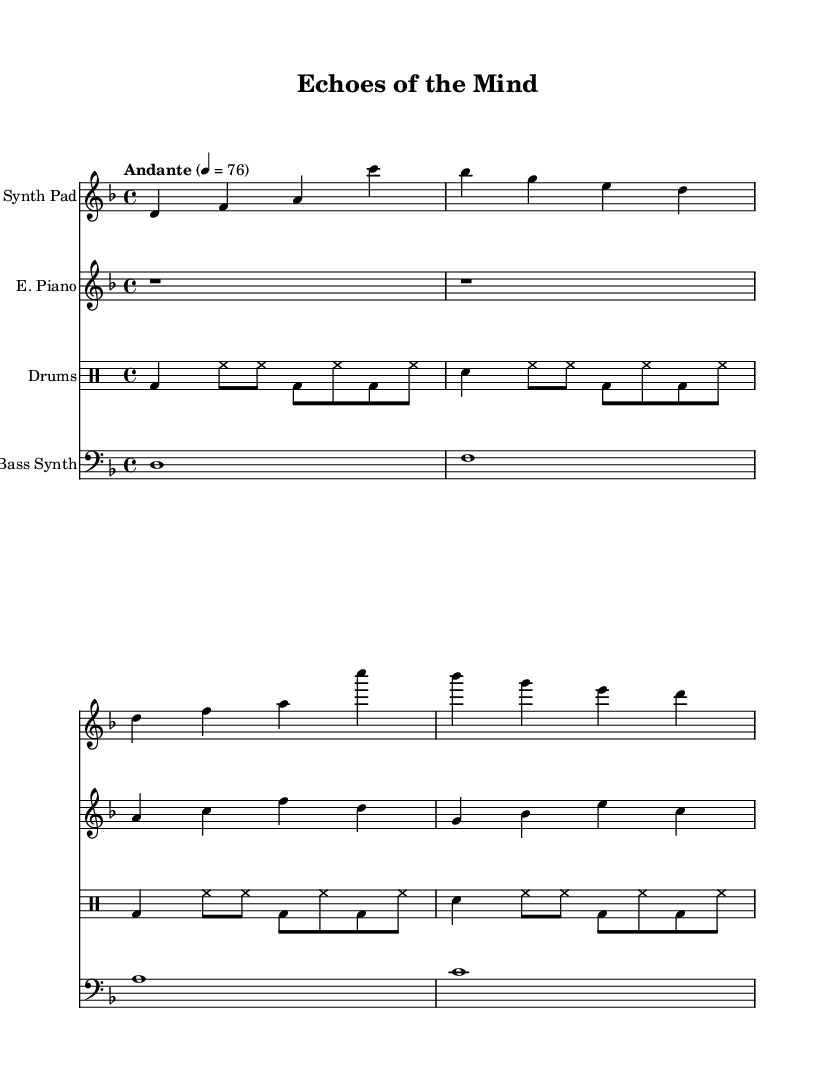What is the key signature of this music? The key signature has two flats, which corresponds to B-flat major or G minor. However, since the music is in D minor, the key signature indicates D minor.
Answer: D minor What is the time signature of this music? The time signature is indicated at the beginning of the piece, showing four beats per measure, which is a common feature for structured rhythmic pieces.
Answer: 4/4 What is the tempo marking given in the sheet music? The tempo marking appears above the staff, indicating the speed at which the piece should be played, specifically that it is to be played at a moderate pace.
Answer: Andante What instrument plays the main melody in this score? By examining the different staves, the Synth Pad is notated first and is an essential part of the atmospheric texture, making it the main melody provider in this piece.
Answer: Synth Pad How many measures does the drum machine part contain? By counting the measures in the drum staff, it is evident that there are four measures, indicated by the way drum rhythms are grouped and repeated in the notation.
Answer: 4 What type of music does this piece represent? The structure and instrumentation, as well as the subdued and repetitive nature of the music, indicate its purpose in film and media, particularly for creating an atmospheric and emotional effect.
Answer: Soundtrack 